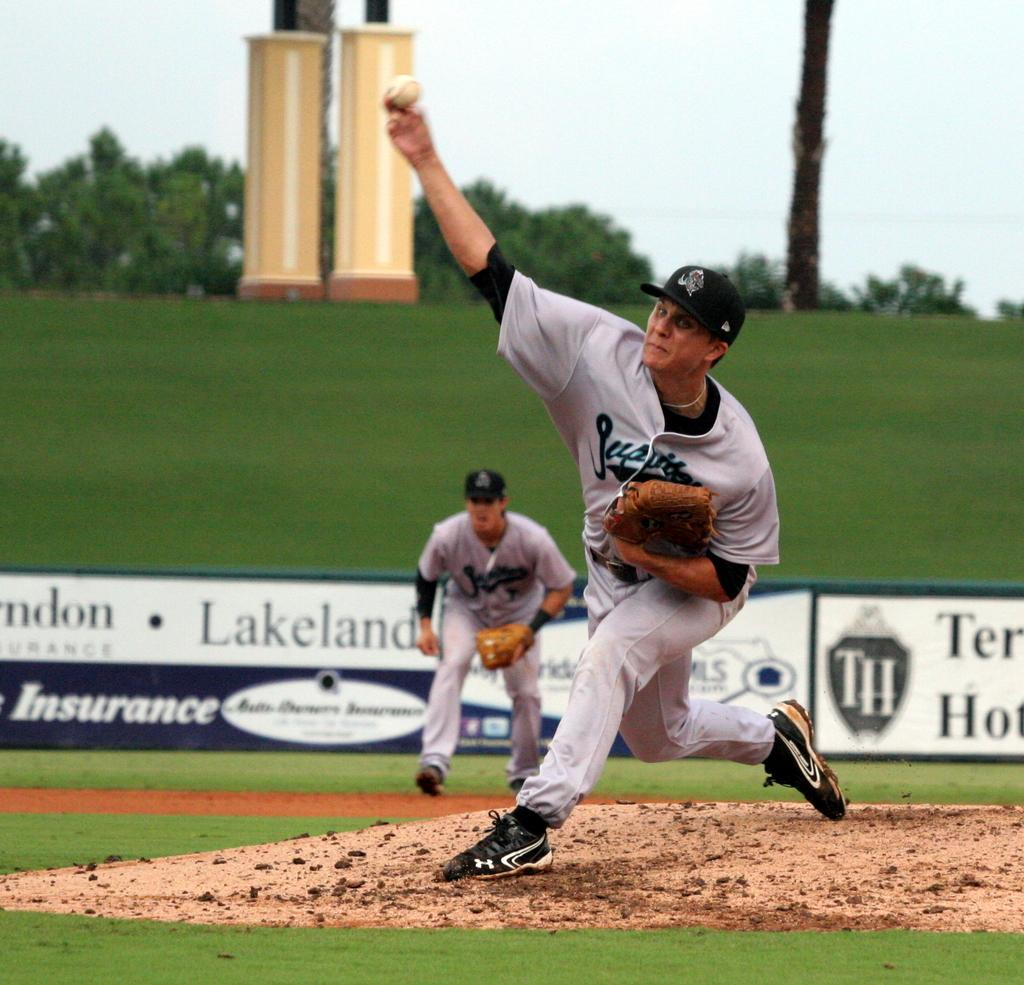<image>
Describe the image concisely. A baseball game that is taking place in a stadium with Lakeland written in the background. 